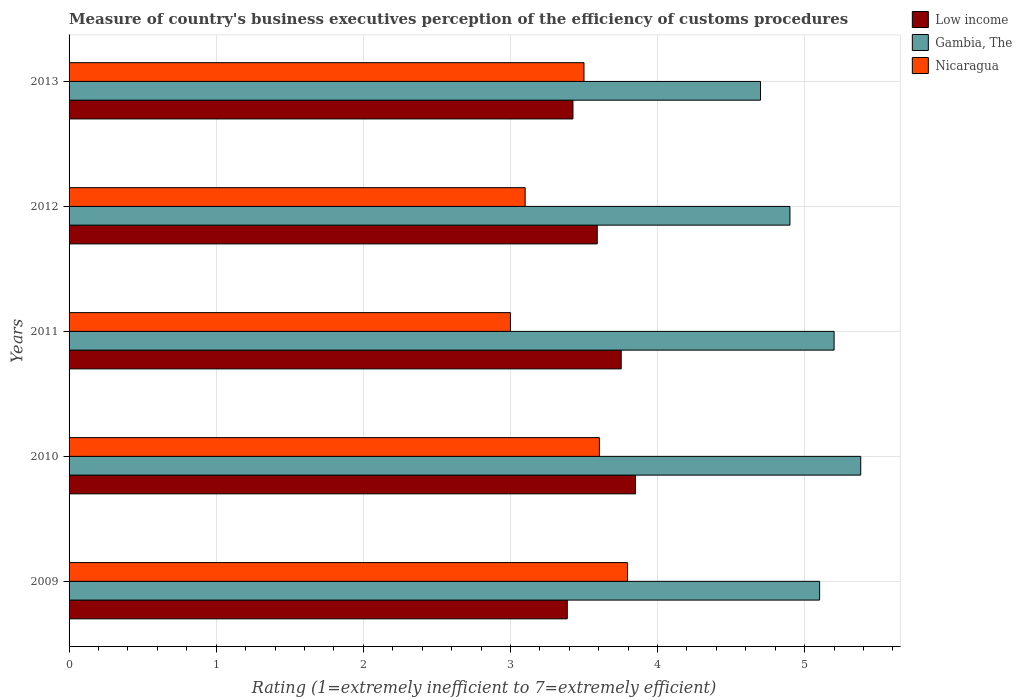How many different coloured bars are there?
Offer a very short reply. 3. How many groups of bars are there?
Provide a short and direct response. 5. Are the number of bars per tick equal to the number of legend labels?
Your answer should be very brief. Yes. How many bars are there on the 4th tick from the top?
Provide a succinct answer. 3. What is the label of the 5th group of bars from the top?
Give a very brief answer. 2009. In how many cases, is the number of bars for a given year not equal to the number of legend labels?
Your response must be concise. 0. What is the rating of the efficiency of customs procedure in Gambia, The in 2012?
Give a very brief answer. 4.9. Across all years, what is the maximum rating of the efficiency of customs procedure in Gambia, The?
Your answer should be very brief. 5.38. What is the total rating of the efficiency of customs procedure in Gambia, The in the graph?
Ensure brevity in your answer.  25.28. What is the difference between the rating of the efficiency of customs procedure in Nicaragua in 2011 and that in 2012?
Offer a very short reply. -0.1. What is the difference between the rating of the efficiency of customs procedure in Gambia, The in 2010 and the rating of the efficiency of customs procedure in Nicaragua in 2009?
Offer a very short reply. 1.59. What is the average rating of the efficiency of customs procedure in Gambia, The per year?
Ensure brevity in your answer.  5.06. In the year 2009, what is the difference between the rating of the efficiency of customs procedure in Nicaragua and rating of the efficiency of customs procedure in Low income?
Provide a succinct answer. 0.41. In how many years, is the rating of the efficiency of customs procedure in Nicaragua greater than 3.4 ?
Keep it short and to the point. 3. What is the ratio of the rating of the efficiency of customs procedure in Gambia, The in 2010 to that in 2011?
Provide a short and direct response. 1.03. Is the rating of the efficiency of customs procedure in Gambia, The in 2009 less than that in 2012?
Give a very brief answer. No. Is the difference between the rating of the efficiency of customs procedure in Nicaragua in 2011 and 2012 greater than the difference between the rating of the efficiency of customs procedure in Low income in 2011 and 2012?
Provide a succinct answer. No. What is the difference between the highest and the second highest rating of the efficiency of customs procedure in Gambia, The?
Your answer should be compact. 0.18. What is the difference between the highest and the lowest rating of the efficiency of customs procedure in Nicaragua?
Provide a succinct answer. 0.8. In how many years, is the rating of the efficiency of customs procedure in Gambia, The greater than the average rating of the efficiency of customs procedure in Gambia, The taken over all years?
Keep it short and to the point. 3. What does the 3rd bar from the top in 2010 represents?
Provide a succinct answer. Low income. What does the 2nd bar from the bottom in 2010 represents?
Your answer should be very brief. Gambia, The. Is it the case that in every year, the sum of the rating of the efficiency of customs procedure in Gambia, The and rating of the efficiency of customs procedure in Nicaragua is greater than the rating of the efficiency of customs procedure in Low income?
Your answer should be very brief. Yes. Are all the bars in the graph horizontal?
Offer a very short reply. Yes. What is the difference between two consecutive major ticks on the X-axis?
Your answer should be very brief. 1. Does the graph contain grids?
Make the answer very short. Yes. Where does the legend appear in the graph?
Ensure brevity in your answer.  Top right. How many legend labels are there?
Make the answer very short. 3. What is the title of the graph?
Provide a succinct answer. Measure of country's business executives perception of the efficiency of customs procedures. What is the label or title of the X-axis?
Offer a very short reply. Rating (1=extremely inefficient to 7=extremely efficient). What is the label or title of the Y-axis?
Give a very brief answer. Years. What is the Rating (1=extremely inefficient to 7=extremely efficient) of Low income in 2009?
Your response must be concise. 3.39. What is the Rating (1=extremely inefficient to 7=extremely efficient) in Gambia, The in 2009?
Make the answer very short. 5.1. What is the Rating (1=extremely inefficient to 7=extremely efficient) in Nicaragua in 2009?
Your answer should be very brief. 3.8. What is the Rating (1=extremely inefficient to 7=extremely efficient) of Low income in 2010?
Make the answer very short. 3.85. What is the Rating (1=extremely inefficient to 7=extremely efficient) of Gambia, The in 2010?
Ensure brevity in your answer.  5.38. What is the Rating (1=extremely inefficient to 7=extremely efficient) of Nicaragua in 2010?
Offer a very short reply. 3.6. What is the Rating (1=extremely inefficient to 7=extremely efficient) in Low income in 2011?
Keep it short and to the point. 3.75. What is the Rating (1=extremely inefficient to 7=extremely efficient) in Nicaragua in 2011?
Give a very brief answer. 3. What is the Rating (1=extremely inefficient to 7=extremely efficient) in Low income in 2012?
Give a very brief answer. 3.59. What is the Rating (1=extremely inefficient to 7=extremely efficient) of Nicaragua in 2012?
Give a very brief answer. 3.1. What is the Rating (1=extremely inefficient to 7=extremely efficient) of Low income in 2013?
Make the answer very short. 3.42. What is the Rating (1=extremely inefficient to 7=extremely efficient) of Gambia, The in 2013?
Offer a terse response. 4.7. What is the Rating (1=extremely inefficient to 7=extremely efficient) in Nicaragua in 2013?
Keep it short and to the point. 3.5. Across all years, what is the maximum Rating (1=extremely inefficient to 7=extremely efficient) of Low income?
Your answer should be very brief. 3.85. Across all years, what is the maximum Rating (1=extremely inefficient to 7=extremely efficient) of Gambia, The?
Give a very brief answer. 5.38. Across all years, what is the maximum Rating (1=extremely inefficient to 7=extremely efficient) of Nicaragua?
Make the answer very short. 3.8. Across all years, what is the minimum Rating (1=extremely inefficient to 7=extremely efficient) of Low income?
Keep it short and to the point. 3.39. Across all years, what is the minimum Rating (1=extremely inefficient to 7=extremely efficient) in Nicaragua?
Keep it short and to the point. 3. What is the total Rating (1=extremely inefficient to 7=extremely efficient) of Low income in the graph?
Your answer should be very brief. 18. What is the total Rating (1=extremely inefficient to 7=extremely efficient) of Gambia, The in the graph?
Your answer should be compact. 25.28. What is the total Rating (1=extremely inefficient to 7=extremely efficient) in Nicaragua in the graph?
Ensure brevity in your answer.  17. What is the difference between the Rating (1=extremely inefficient to 7=extremely efficient) of Low income in 2009 and that in 2010?
Keep it short and to the point. -0.46. What is the difference between the Rating (1=extremely inefficient to 7=extremely efficient) in Gambia, The in 2009 and that in 2010?
Give a very brief answer. -0.28. What is the difference between the Rating (1=extremely inefficient to 7=extremely efficient) in Nicaragua in 2009 and that in 2010?
Keep it short and to the point. 0.19. What is the difference between the Rating (1=extremely inefficient to 7=extremely efficient) in Low income in 2009 and that in 2011?
Offer a very short reply. -0.37. What is the difference between the Rating (1=extremely inefficient to 7=extremely efficient) in Gambia, The in 2009 and that in 2011?
Give a very brief answer. -0.1. What is the difference between the Rating (1=extremely inefficient to 7=extremely efficient) in Nicaragua in 2009 and that in 2011?
Your answer should be very brief. 0.8. What is the difference between the Rating (1=extremely inefficient to 7=extremely efficient) of Low income in 2009 and that in 2012?
Provide a succinct answer. -0.2. What is the difference between the Rating (1=extremely inefficient to 7=extremely efficient) of Gambia, The in 2009 and that in 2012?
Offer a very short reply. 0.2. What is the difference between the Rating (1=extremely inefficient to 7=extremely efficient) of Nicaragua in 2009 and that in 2012?
Ensure brevity in your answer.  0.7. What is the difference between the Rating (1=extremely inefficient to 7=extremely efficient) of Low income in 2009 and that in 2013?
Ensure brevity in your answer.  -0.04. What is the difference between the Rating (1=extremely inefficient to 7=extremely efficient) in Gambia, The in 2009 and that in 2013?
Offer a terse response. 0.4. What is the difference between the Rating (1=extremely inefficient to 7=extremely efficient) of Nicaragua in 2009 and that in 2013?
Provide a succinct answer. 0.3. What is the difference between the Rating (1=extremely inefficient to 7=extremely efficient) in Low income in 2010 and that in 2011?
Offer a terse response. 0.1. What is the difference between the Rating (1=extremely inefficient to 7=extremely efficient) of Gambia, The in 2010 and that in 2011?
Your response must be concise. 0.18. What is the difference between the Rating (1=extremely inefficient to 7=extremely efficient) of Nicaragua in 2010 and that in 2011?
Keep it short and to the point. 0.6. What is the difference between the Rating (1=extremely inefficient to 7=extremely efficient) of Low income in 2010 and that in 2012?
Your answer should be compact. 0.26. What is the difference between the Rating (1=extremely inefficient to 7=extremely efficient) of Gambia, The in 2010 and that in 2012?
Keep it short and to the point. 0.48. What is the difference between the Rating (1=extremely inefficient to 7=extremely efficient) of Nicaragua in 2010 and that in 2012?
Offer a terse response. 0.5. What is the difference between the Rating (1=extremely inefficient to 7=extremely efficient) of Low income in 2010 and that in 2013?
Provide a short and direct response. 0.43. What is the difference between the Rating (1=extremely inefficient to 7=extremely efficient) in Gambia, The in 2010 and that in 2013?
Provide a short and direct response. 0.68. What is the difference between the Rating (1=extremely inefficient to 7=extremely efficient) of Nicaragua in 2010 and that in 2013?
Provide a succinct answer. 0.1. What is the difference between the Rating (1=extremely inefficient to 7=extremely efficient) of Low income in 2011 and that in 2012?
Make the answer very short. 0.16. What is the difference between the Rating (1=extremely inefficient to 7=extremely efficient) of Nicaragua in 2011 and that in 2012?
Your answer should be very brief. -0.1. What is the difference between the Rating (1=extremely inefficient to 7=extremely efficient) of Low income in 2011 and that in 2013?
Your answer should be very brief. 0.33. What is the difference between the Rating (1=extremely inefficient to 7=extremely efficient) of Nicaragua in 2011 and that in 2013?
Make the answer very short. -0.5. What is the difference between the Rating (1=extremely inefficient to 7=extremely efficient) of Low income in 2012 and that in 2013?
Offer a very short reply. 0.17. What is the difference between the Rating (1=extremely inefficient to 7=extremely efficient) of Gambia, The in 2012 and that in 2013?
Provide a short and direct response. 0.2. What is the difference between the Rating (1=extremely inefficient to 7=extremely efficient) of Nicaragua in 2012 and that in 2013?
Make the answer very short. -0.4. What is the difference between the Rating (1=extremely inefficient to 7=extremely efficient) of Low income in 2009 and the Rating (1=extremely inefficient to 7=extremely efficient) of Gambia, The in 2010?
Make the answer very short. -1.99. What is the difference between the Rating (1=extremely inefficient to 7=extremely efficient) of Low income in 2009 and the Rating (1=extremely inefficient to 7=extremely efficient) of Nicaragua in 2010?
Give a very brief answer. -0.22. What is the difference between the Rating (1=extremely inefficient to 7=extremely efficient) in Gambia, The in 2009 and the Rating (1=extremely inefficient to 7=extremely efficient) in Nicaragua in 2010?
Keep it short and to the point. 1.5. What is the difference between the Rating (1=extremely inefficient to 7=extremely efficient) in Low income in 2009 and the Rating (1=extremely inefficient to 7=extremely efficient) in Gambia, The in 2011?
Make the answer very short. -1.81. What is the difference between the Rating (1=extremely inefficient to 7=extremely efficient) in Low income in 2009 and the Rating (1=extremely inefficient to 7=extremely efficient) in Nicaragua in 2011?
Keep it short and to the point. 0.39. What is the difference between the Rating (1=extremely inefficient to 7=extremely efficient) in Gambia, The in 2009 and the Rating (1=extremely inefficient to 7=extremely efficient) in Nicaragua in 2011?
Provide a short and direct response. 2.1. What is the difference between the Rating (1=extremely inefficient to 7=extremely efficient) in Low income in 2009 and the Rating (1=extremely inefficient to 7=extremely efficient) in Gambia, The in 2012?
Your response must be concise. -1.51. What is the difference between the Rating (1=extremely inefficient to 7=extremely efficient) of Low income in 2009 and the Rating (1=extremely inefficient to 7=extremely efficient) of Nicaragua in 2012?
Your answer should be very brief. 0.29. What is the difference between the Rating (1=extremely inefficient to 7=extremely efficient) of Gambia, The in 2009 and the Rating (1=extremely inefficient to 7=extremely efficient) of Nicaragua in 2012?
Make the answer very short. 2. What is the difference between the Rating (1=extremely inefficient to 7=extremely efficient) in Low income in 2009 and the Rating (1=extremely inefficient to 7=extremely efficient) in Gambia, The in 2013?
Your response must be concise. -1.31. What is the difference between the Rating (1=extremely inefficient to 7=extremely efficient) of Low income in 2009 and the Rating (1=extremely inefficient to 7=extremely efficient) of Nicaragua in 2013?
Keep it short and to the point. -0.11. What is the difference between the Rating (1=extremely inefficient to 7=extremely efficient) in Gambia, The in 2009 and the Rating (1=extremely inefficient to 7=extremely efficient) in Nicaragua in 2013?
Keep it short and to the point. 1.6. What is the difference between the Rating (1=extremely inefficient to 7=extremely efficient) in Low income in 2010 and the Rating (1=extremely inefficient to 7=extremely efficient) in Gambia, The in 2011?
Your answer should be very brief. -1.35. What is the difference between the Rating (1=extremely inefficient to 7=extremely efficient) in Low income in 2010 and the Rating (1=extremely inefficient to 7=extremely efficient) in Nicaragua in 2011?
Make the answer very short. 0.85. What is the difference between the Rating (1=extremely inefficient to 7=extremely efficient) in Gambia, The in 2010 and the Rating (1=extremely inefficient to 7=extremely efficient) in Nicaragua in 2011?
Your response must be concise. 2.38. What is the difference between the Rating (1=extremely inefficient to 7=extremely efficient) in Low income in 2010 and the Rating (1=extremely inefficient to 7=extremely efficient) in Gambia, The in 2012?
Provide a succinct answer. -1.05. What is the difference between the Rating (1=extremely inefficient to 7=extremely efficient) of Low income in 2010 and the Rating (1=extremely inefficient to 7=extremely efficient) of Nicaragua in 2012?
Keep it short and to the point. 0.75. What is the difference between the Rating (1=extremely inefficient to 7=extremely efficient) in Gambia, The in 2010 and the Rating (1=extremely inefficient to 7=extremely efficient) in Nicaragua in 2012?
Provide a short and direct response. 2.28. What is the difference between the Rating (1=extremely inefficient to 7=extremely efficient) in Low income in 2010 and the Rating (1=extremely inefficient to 7=extremely efficient) in Gambia, The in 2013?
Provide a succinct answer. -0.85. What is the difference between the Rating (1=extremely inefficient to 7=extremely efficient) in Low income in 2010 and the Rating (1=extremely inefficient to 7=extremely efficient) in Nicaragua in 2013?
Your response must be concise. 0.35. What is the difference between the Rating (1=extremely inefficient to 7=extremely efficient) of Gambia, The in 2010 and the Rating (1=extremely inefficient to 7=extremely efficient) of Nicaragua in 2013?
Ensure brevity in your answer.  1.88. What is the difference between the Rating (1=extremely inefficient to 7=extremely efficient) in Low income in 2011 and the Rating (1=extremely inefficient to 7=extremely efficient) in Gambia, The in 2012?
Your response must be concise. -1.15. What is the difference between the Rating (1=extremely inefficient to 7=extremely efficient) of Low income in 2011 and the Rating (1=extremely inefficient to 7=extremely efficient) of Nicaragua in 2012?
Offer a terse response. 0.65. What is the difference between the Rating (1=extremely inefficient to 7=extremely efficient) of Low income in 2011 and the Rating (1=extremely inefficient to 7=extremely efficient) of Gambia, The in 2013?
Your answer should be very brief. -0.95. What is the difference between the Rating (1=extremely inefficient to 7=extremely efficient) of Low income in 2011 and the Rating (1=extremely inefficient to 7=extremely efficient) of Nicaragua in 2013?
Make the answer very short. 0.25. What is the difference between the Rating (1=extremely inefficient to 7=extremely efficient) of Low income in 2012 and the Rating (1=extremely inefficient to 7=extremely efficient) of Gambia, The in 2013?
Your answer should be compact. -1.11. What is the difference between the Rating (1=extremely inefficient to 7=extremely efficient) in Low income in 2012 and the Rating (1=extremely inefficient to 7=extremely efficient) in Nicaragua in 2013?
Offer a terse response. 0.09. What is the difference between the Rating (1=extremely inefficient to 7=extremely efficient) in Gambia, The in 2012 and the Rating (1=extremely inefficient to 7=extremely efficient) in Nicaragua in 2013?
Offer a very short reply. 1.4. What is the average Rating (1=extremely inefficient to 7=extremely efficient) of Low income per year?
Offer a very short reply. 3.6. What is the average Rating (1=extremely inefficient to 7=extremely efficient) in Gambia, The per year?
Offer a very short reply. 5.06. What is the average Rating (1=extremely inefficient to 7=extremely efficient) of Nicaragua per year?
Offer a very short reply. 3.4. In the year 2009, what is the difference between the Rating (1=extremely inefficient to 7=extremely efficient) of Low income and Rating (1=extremely inefficient to 7=extremely efficient) of Gambia, The?
Your answer should be very brief. -1.72. In the year 2009, what is the difference between the Rating (1=extremely inefficient to 7=extremely efficient) in Low income and Rating (1=extremely inefficient to 7=extremely efficient) in Nicaragua?
Offer a terse response. -0.41. In the year 2009, what is the difference between the Rating (1=extremely inefficient to 7=extremely efficient) of Gambia, The and Rating (1=extremely inefficient to 7=extremely efficient) of Nicaragua?
Provide a short and direct response. 1.31. In the year 2010, what is the difference between the Rating (1=extremely inefficient to 7=extremely efficient) of Low income and Rating (1=extremely inefficient to 7=extremely efficient) of Gambia, The?
Your answer should be very brief. -1.53. In the year 2010, what is the difference between the Rating (1=extremely inefficient to 7=extremely efficient) of Low income and Rating (1=extremely inefficient to 7=extremely efficient) of Nicaragua?
Give a very brief answer. 0.25. In the year 2010, what is the difference between the Rating (1=extremely inefficient to 7=extremely efficient) of Gambia, The and Rating (1=extremely inefficient to 7=extremely efficient) of Nicaragua?
Offer a very short reply. 1.78. In the year 2011, what is the difference between the Rating (1=extremely inefficient to 7=extremely efficient) of Low income and Rating (1=extremely inefficient to 7=extremely efficient) of Gambia, The?
Ensure brevity in your answer.  -1.45. In the year 2011, what is the difference between the Rating (1=extremely inefficient to 7=extremely efficient) in Low income and Rating (1=extremely inefficient to 7=extremely efficient) in Nicaragua?
Provide a succinct answer. 0.75. In the year 2012, what is the difference between the Rating (1=extremely inefficient to 7=extremely efficient) in Low income and Rating (1=extremely inefficient to 7=extremely efficient) in Gambia, The?
Give a very brief answer. -1.31. In the year 2012, what is the difference between the Rating (1=extremely inefficient to 7=extremely efficient) of Low income and Rating (1=extremely inefficient to 7=extremely efficient) of Nicaragua?
Ensure brevity in your answer.  0.49. In the year 2013, what is the difference between the Rating (1=extremely inefficient to 7=extremely efficient) of Low income and Rating (1=extremely inefficient to 7=extremely efficient) of Gambia, The?
Keep it short and to the point. -1.27. In the year 2013, what is the difference between the Rating (1=extremely inefficient to 7=extremely efficient) of Low income and Rating (1=extremely inefficient to 7=extremely efficient) of Nicaragua?
Offer a terse response. -0.07. What is the ratio of the Rating (1=extremely inefficient to 7=extremely efficient) of Low income in 2009 to that in 2010?
Give a very brief answer. 0.88. What is the ratio of the Rating (1=extremely inefficient to 7=extremely efficient) of Gambia, The in 2009 to that in 2010?
Keep it short and to the point. 0.95. What is the ratio of the Rating (1=extremely inefficient to 7=extremely efficient) of Nicaragua in 2009 to that in 2010?
Ensure brevity in your answer.  1.05. What is the ratio of the Rating (1=extremely inefficient to 7=extremely efficient) in Low income in 2009 to that in 2011?
Your answer should be compact. 0.9. What is the ratio of the Rating (1=extremely inefficient to 7=extremely efficient) of Gambia, The in 2009 to that in 2011?
Give a very brief answer. 0.98. What is the ratio of the Rating (1=extremely inefficient to 7=extremely efficient) of Nicaragua in 2009 to that in 2011?
Your answer should be compact. 1.27. What is the ratio of the Rating (1=extremely inefficient to 7=extremely efficient) in Low income in 2009 to that in 2012?
Provide a succinct answer. 0.94. What is the ratio of the Rating (1=extremely inefficient to 7=extremely efficient) in Gambia, The in 2009 to that in 2012?
Offer a terse response. 1.04. What is the ratio of the Rating (1=extremely inefficient to 7=extremely efficient) of Nicaragua in 2009 to that in 2012?
Offer a terse response. 1.22. What is the ratio of the Rating (1=extremely inefficient to 7=extremely efficient) of Low income in 2009 to that in 2013?
Your response must be concise. 0.99. What is the ratio of the Rating (1=extremely inefficient to 7=extremely efficient) of Gambia, The in 2009 to that in 2013?
Offer a terse response. 1.09. What is the ratio of the Rating (1=extremely inefficient to 7=extremely efficient) of Nicaragua in 2009 to that in 2013?
Offer a terse response. 1.08. What is the ratio of the Rating (1=extremely inefficient to 7=extremely efficient) of Low income in 2010 to that in 2011?
Make the answer very short. 1.03. What is the ratio of the Rating (1=extremely inefficient to 7=extremely efficient) in Gambia, The in 2010 to that in 2011?
Make the answer very short. 1.03. What is the ratio of the Rating (1=extremely inefficient to 7=extremely efficient) of Nicaragua in 2010 to that in 2011?
Give a very brief answer. 1.2. What is the ratio of the Rating (1=extremely inefficient to 7=extremely efficient) in Low income in 2010 to that in 2012?
Make the answer very short. 1.07. What is the ratio of the Rating (1=extremely inefficient to 7=extremely efficient) of Gambia, The in 2010 to that in 2012?
Ensure brevity in your answer.  1.1. What is the ratio of the Rating (1=extremely inefficient to 7=extremely efficient) in Nicaragua in 2010 to that in 2012?
Ensure brevity in your answer.  1.16. What is the ratio of the Rating (1=extremely inefficient to 7=extremely efficient) of Low income in 2010 to that in 2013?
Provide a short and direct response. 1.12. What is the ratio of the Rating (1=extremely inefficient to 7=extremely efficient) of Gambia, The in 2010 to that in 2013?
Your response must be concise. 1.14. What is the ratio of the Rating (1=extremely inefficient to 7=extremely efficient) of Nicaragua in 2010 to that in 2013?
Offer a terse response. 1.03. What is the ratio of the Rating (1=extremely inefficient to 7=extremely efficient) in Low income in 2011 to that in 2012?
Offer a very short reply. 1.05. What is the ratio of the Rating (1=extremely inefficient to 7=extremely efficient) of Gambia, The in 2011 to that in 2012?
Keep it short and to the point. 1.06. What is the ratio of the Rating (1=extremely inefficient to 7=extremely efficient) of Low income in 2011 to that in 2013?
Provide a succinct answer. 1.1. What is the ratio of the Rating (1=extremely inefficient to 7=extremely efficient) of Gambia, The in 2011 to that in 2013?
Your answer should be very brief. 1.11. What is the ratio of the Rating (1=extremely inefficient to 7=extremely efficient) of Low income in 2012 to that in 2013?
Your answer should be very brief. 1.05. What is the ratio of the Rating (1=extremely inefficient to 7=extremely efficient) in Gambia, The in 2012 to that in 2013?
Ensure brevity in your answer.  1.04. What is the ratio of the Rating (1=extremely inefficient to 7=extremely efficient) of Nicaragua in 2012 to that in 2013?
Give a very brief answer. 0.89. What is the difference between the highest and the second highest Rating (1=extremely inefficient to 7=extremely efficient) of Low income?
Your answer should be very brief. 0.1. What is the difference between the highest and the second highest Rating (1=extremely inefficient to 7=extremely efficient) in Gambia, The?
Ensure brevity in your answer.  0.18. What is the difference between the highest and the second highest Rating (1=extremely inefficient to 7=extremely efficient) of Nicaragua?
Keep it short and to the point. 0.19. What is the difference between the highest and the lowest Rating (1=extremely inefficient to 7=extremely efficient) of Low income?
Offer a terse response. 0.46. What is the difference between the highest and the lowest Rating (1=extremely inefficient to 7=extremely efficient) in Gambia, The?
Give a very brief answer. 0.68. What is the difference between the highest and the lowest Rating (1=extremely inefficient to 7=extremely efficient) in Nicaragua?
Ensure brevity in your answer.  0.8. 